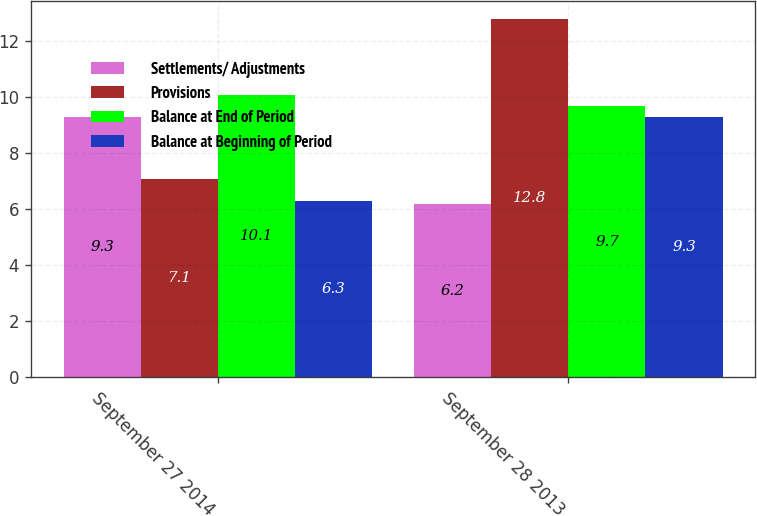Convert chart to OTSL. <chart><loc_0><loc_0><loc_500><loc_500><stacked_bar_chart><ecel><fcel>September 27 2014<fcel>September 28 2013<nl><fcel>Settlements/ Adjustments<fcel>9.3<fcel>6.2<nl><fcel>Provisions<fcel>7.1<fcel>12.8<nl><fcel>Balance at End of Period<fcel>10.1<fcel>9.7<nl><fcel>Balance at Beginning of Period<fcel>6.3<fcel>9.3<nl></chart> 